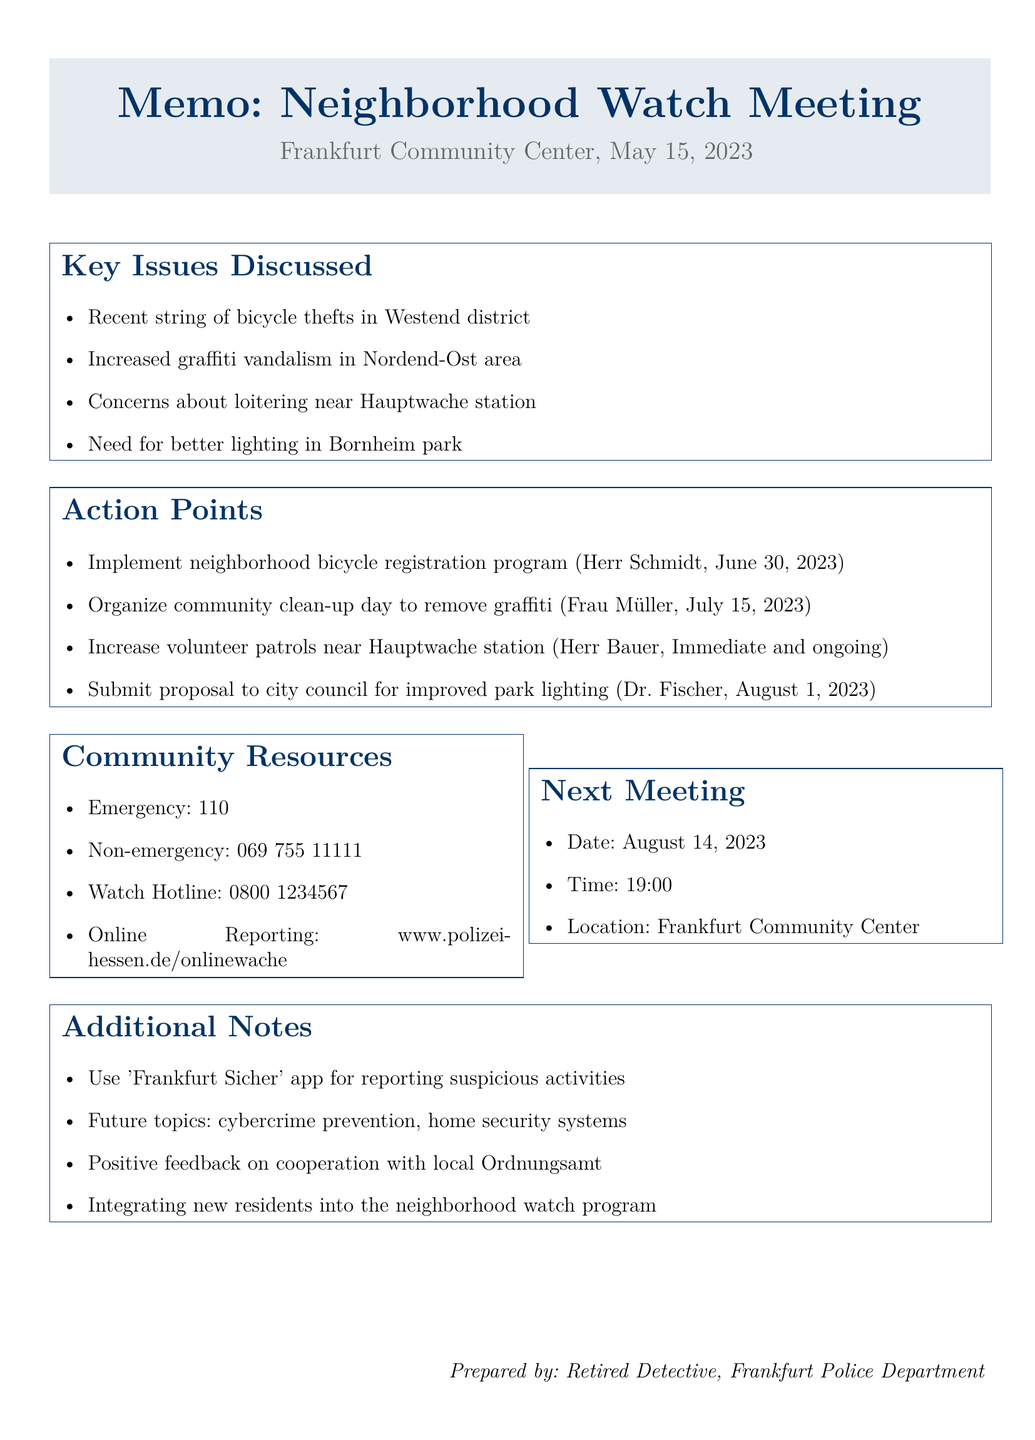What date was the neighborhood watch meeting? The date of the meeting is specifically mentioned in the document.
Answer: May 15, 2023 Who was the guest speaker at the meeting? The document lists the guest speaker's name and affiliation.
Answer: Oberkommissar Klaus Weber What are the community resources for emergency contact? The document provides a specific emergency number for the community.
Answer: 110 What is one key issue discussed regarding community safety? The document outlines several key issues discussed, highlighting public safety concerns.
Answer: Bicycle thefts What is the deadline for implementing the bicycle registration program? The document specifies a deadline for a particular action point.
Answer: June 30, 2023 Which area showed an increased incidence of graffiti vandalism? The document explicitly mentions areas affected by crime.
Answer: Nordend-Ost What is the next meeting date for the neighborhood watch? The document provides the date for the subsequent meeting.
Answer: August 14, 2023 Who is responsible for organizing the community clean-up day? The document identifies the individual responsible for a specific task.
Answer: Frau Müller What suggestion for future topics was made during the meeting? The document references suggested topics for future discussions.
Answer: Cybercrime prevention 